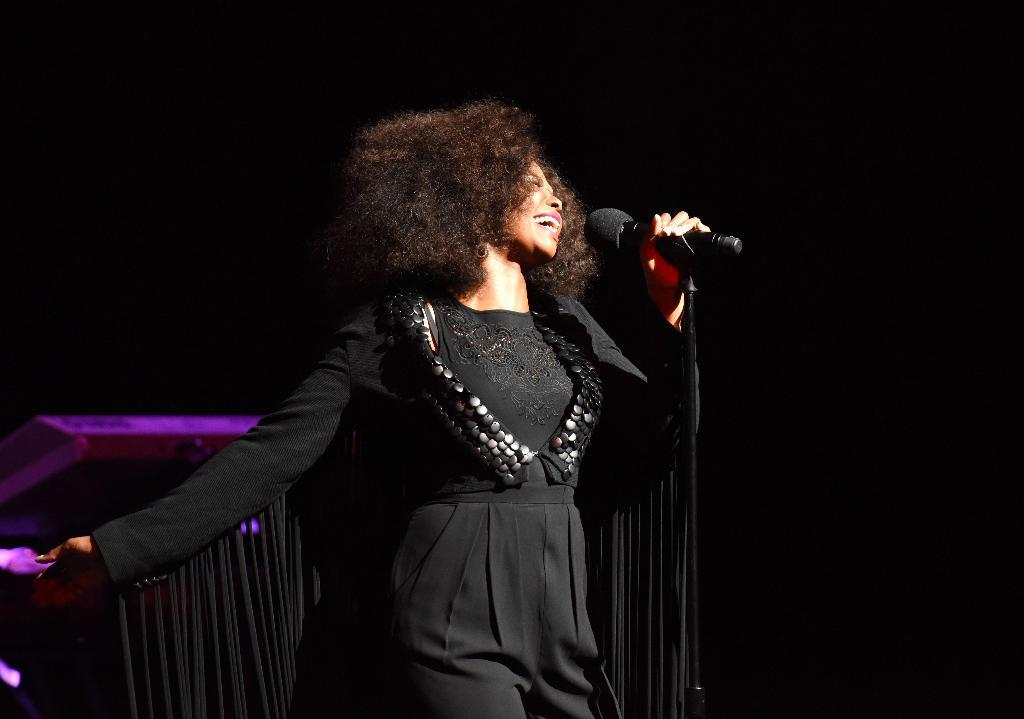Who is the main subject in the foreground of the image? There is a lady in the foreground of the image. What is the lady holding in her hand? The lady is holding a mic. What is the lady doing in the image? The lady is singing. Can you describe the background of the image? The background of the image is not clear. What type of scarecrow can be seen in the image? There is no scarecrow present in the image. What is the reason for the lady singing in the image? The image does not provide information about the reason for the lady singing. 